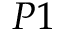Convert formula to latex. <formula><loc_0><loc_0><loc_500><loc_500>P 1</formula> 